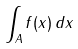<formula> <loc_0><loc_0><loc_500><loc_500>\int _ { A } f ( x ) \, d x</formula> 